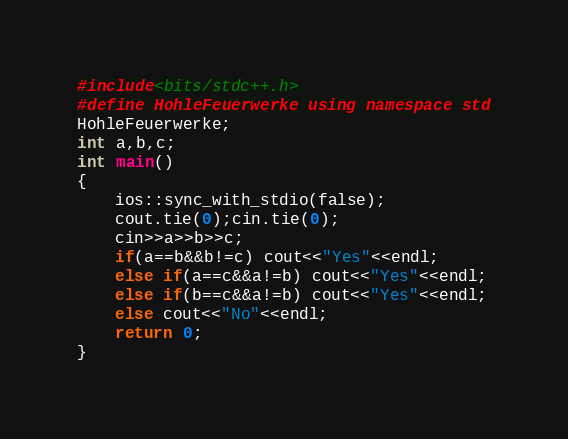<code> <loc_0><loc_0><loc_500><loc_500><_C++_>#include<bits/stdc++.h>
#define HohleFeuerwerke using namespace std
HohleFeuerwerke;
int a,b,c;
int main()
{
	ios::sync_with_stdio(false);
	cout.tie(0);cin.tie(0);
	cin>>a>>b>>c;
	if(a==b&&b!=c) cout<<"Yes"<<endl;
	else if(a==c&&a!=b) cout<<"Yes"<<endl;
	else if(b==c&&a!=b) cout<<"Yes"<<endl;
	else cout<<"No"<<endl;
	return 0;
}</code> 